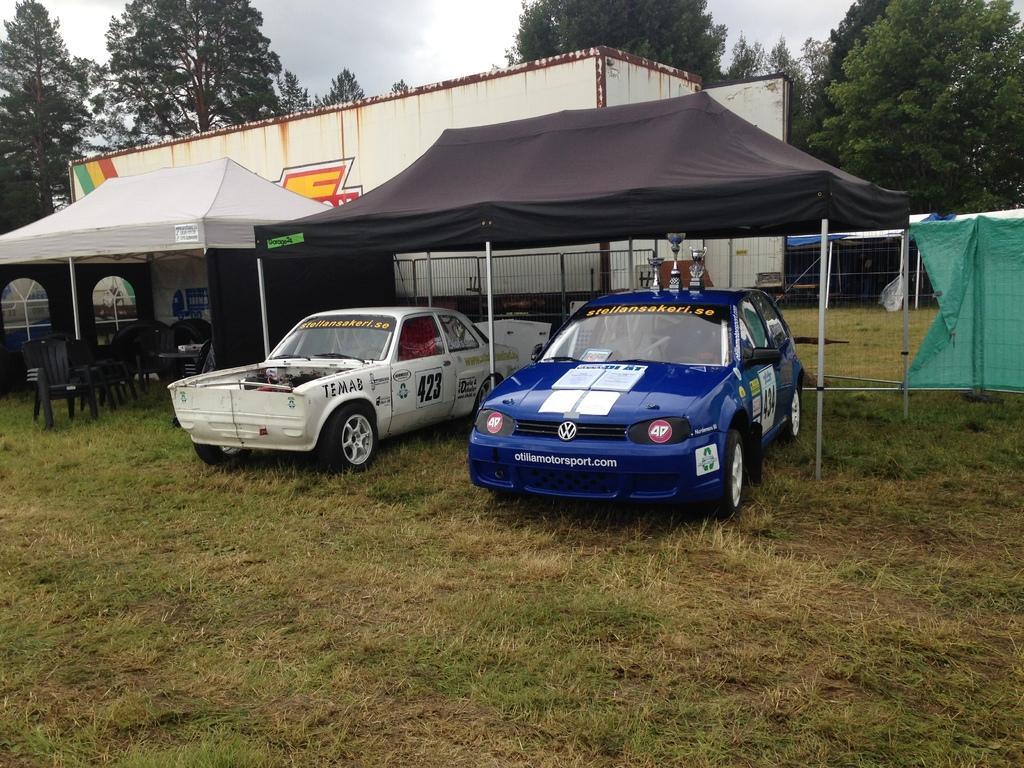Can you describe this image briefly? In the image there are two cars under a tent with tables and chairs on the left side on the grassland and behind there is a fence with a building behind it and trees over the background and above its sky. 